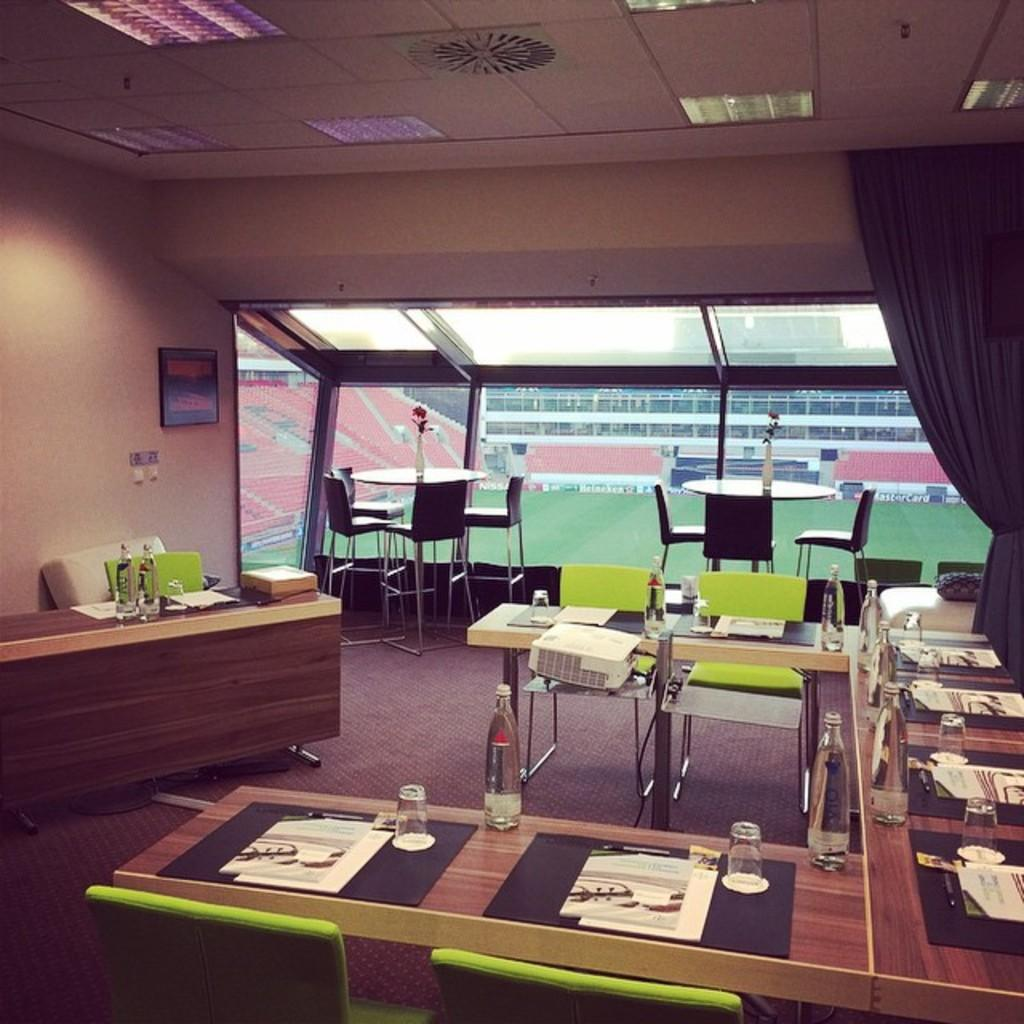What type of structure can be seen in the image? There is a wall in the image. What is hanging on the wall in the image? There is a photo frame in the image. What type of furniture is present in the image? There are chairs and tables in the image. What device is used for displaying images or videos in the image? There is a projector in the image. What type of window treatment is present in the image? There are curtains in the image. What items are on the table in the image? There are glasses and bottles on the table. Where is the basket of fruit located in the image? There is no basket of fruit present in the image. What type of card game is being played in the image? There is no card game present in the image. 